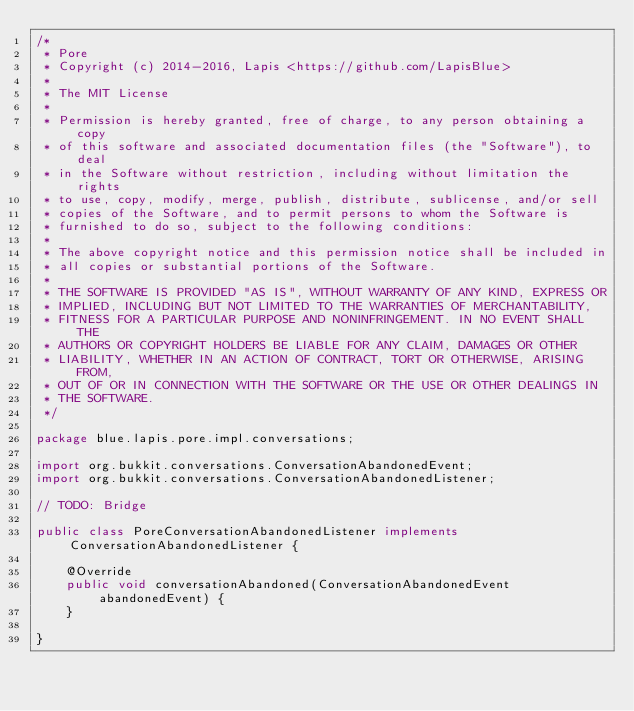<code> <loc_0><loc_0><loc_500><loc_500><_Java_>/*
 * Pore
 * Copyright (c) 2014-2016, Lapis <https://github.com/LapisBlue>
 *
 * The MIT License
 *
 * Permission is hereby granted, free of charge, to any person obtaining a copy
 * of this software and associated documentation files (the "Software"), to deal
 * in the Software without restriction, including without limitation the rights
 * to use, copy, modify, merge, publish, distribute, sublicense, and/or sell
 * copies of the Software, and to permit persons to whom the Software is
 * furnished to do so, subject to the following conditions:
 *
 * The above copyright notice and this permission notice shall be included in
 * all copies or substantial portions of the Software.
 *
 * THE SOFTWARE IS PROVIDED "AS IS", WITHOUT WARRANTY OF ANY KIND, EXPRESS OR
 * IMPLIED, INCLUDING BUT NOT LIMITED TO THE WARRANTIES OF MERCHANTABILITY,
 * FITNESS FOR A PARTICULAR PURPOSE AND NONINFRINGEMENT. IN NO EVENT SHALL THE
 * AUTHORS OR COPYRIGHT HOLDERS BE LIABLE FOR ANY CLAIM, DAMAGES OR OTHER
 * LIABILITY, WHETHER IN AN ACTION OF CONTRACT, TORT OR OTHERWISE, ARISING FROM,
 * OUT OF OR IN CONNECTION WITH THE SOFTWARE OR THE USE OR OTHER DEALINGS IN
 * THE SOFTWARE.
 */

package blue.lapis.pore.impl.conversations;

import org.bukkit.conversations.ConversationAbandonedEvent;
import org.bukkit.conversations.ConversationAbandonedListener;

// TODO: Bridge

public class PoreConversationAbandonedListener implements ConversationAbandonedListener {

    @Override
    public void conversationAbandoned(ConversationAbandonedEvent abandonedEvent) {
    }

}
</code> 